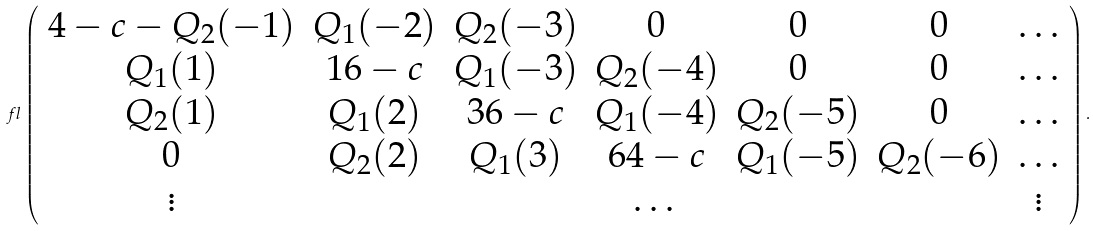<formula> <loc_0><loc_0><loc_500><loc_500>\ f l \left ( \begin{array} { c c c c c c c } 4 - c - Q _ { 2 } ( - 1 ) & Q _ { 1 } ( - 2 ) & Q _ { 2 } ( - 3 ) & 0 & 0 & 0 & \dots \\ Q _ { 1 } ( 1 ) & 1 6 - c & Q _ { 1 } ( - 3 ) & Q _ { 2 } ( - 4 ) & 0 & 0 & \dots \\ Q _ { 2 } ( 1 ) & Q _ { 1 } ( 2 ) & 3 6 - c & Q _ { 1 } ( - 4 ) & Q _ { 2 } ( - 5 ) & 0 & \dots \\ 0 & Q _ { 2 } ( 2 ) & Q _ { 1 } ( 3 ) & 6 4 - c & Q _ { 1 } ( - 5 ) & Q _ { 2 } ( - 6 ) & \dots \\ \vdots & & & \dots & & & \vdots \end{array} \right ) .</formula> 